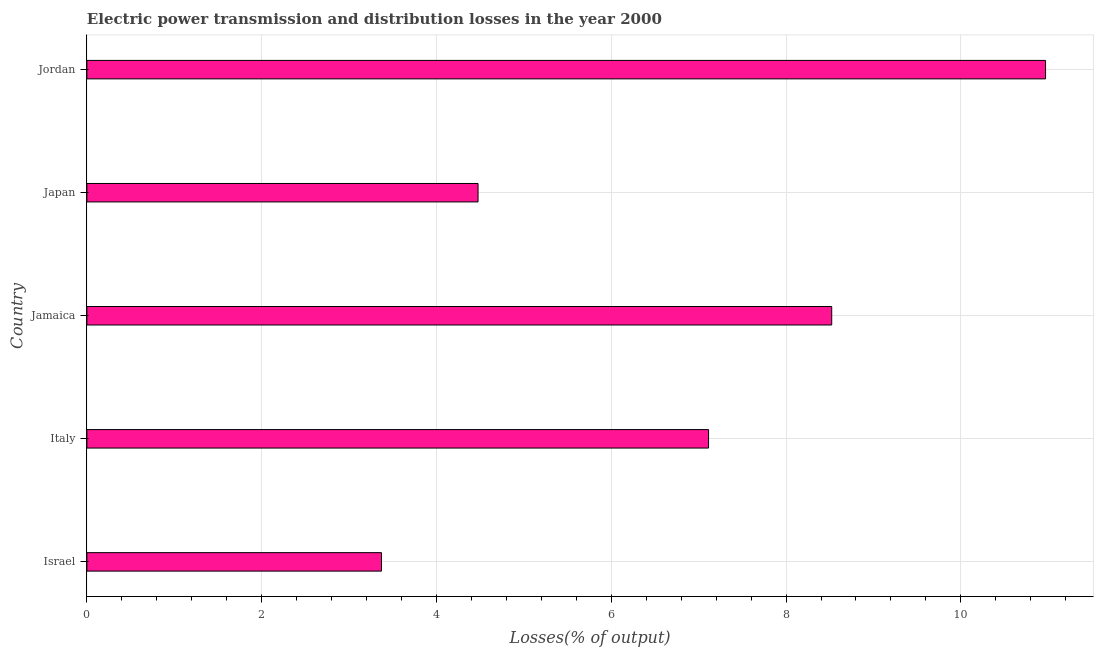Does the graph contain grids?
Your response must be concise. Yes. What is the title of the graph?
Offer a terse response. Electric power transmission and distribution losses in the year 2000. What is the label or title of the X-axis?
Your answer should be very brief. Losses(% of output). What is the electric power transmission and distribution losses in Israel?
Ensure brevity in your answer.  3.37. Across all countries, what is the maximum electric power transmission and distribution losses?
Your answer should be compact. 10.97. Across all countries, what is the minimum electric power transmission and distribution losses?
Provide a short and direct response. 3.37. In which country was the electric power transmission and distribution losses maximum?
Give a very brief answer. Jordan. What is the sum of the electric power transmission and distribution losses?
Your response must be concise. 34.45. What is the difference between the electric power transmission and distribution losses in Japan and Jordan?
Ensure brevity in your answer.  -6.49. What is the average electric power transmission and distribution losses per country?
Offer a very short reply. 6.89. What is the median electric power transmission and distribution losses?
Keep it short and to the point. 7.11. In how many countries, is the electric power transmission and distribution losses greater than 6 %?
Provide a short and direct response. 3. What is the ratio of the electric power transmission and distribution losses in Israel to that in Italy?
Ensure brevity in your answer.  0.47. What is the difference between the highest and the second highest electric power transmission and distribution losses?
Offer a very short reply. 2.45. What is the difference between the highest and the lowest electric power transmission and distribution losses?
Give a very brief answer. 7.6. Are the values on the major ticks of X-axis written in scientific E-notation?
Your answer should be compact. No. What is the Losses(% of output) of Israel?
Ensure brevity in your answer.  3.37. What is the Losses(% of output) of Italy?
Your response must be concise. 7.11. What is the Losses(% of output) in Jamaica?
Give a very brief answer. 8.52. What is the Losses(% of output) of Japan?
Ensure brevity in your answer.  4.48. What is the Losses(% of output) of Jordan?
Give a very brief answer. 10.97. What is the difference between the Losses(% of output) in Israel and Italy?
Ensure brevity in your answer.  -3.74. What is the difference between the Losses(% of output) in Israel and Jamaica?
Your answer should be compact. -5.15. What is the difference between the Losses(% of output) in Israel and Japan?
Your answer should be compact. -1.1. What is the difference between the Losses(% of output) in Israel and Jordan?
Your response must be concise. -7.6. What is the difference between the Losses(% of output) in Italy and Jamaica?
Your answer should be compact. -1.41. What is the difference between the Losses(% of output) in Italy and Japan?
Ensure brevity in your answer.  2.64. What is the difference between the Losses(% of output) in Italy and Jordan?
Your answer should be compact. -3.86. What is the difference between the Losses(% of output) in Jamaica and Japan?
Offer a terse response. 4.05. What is the difference between the Losses(% of output) in Jamaica and Jordan?
Provide a short and direct response. -2.45. What is the difference between the Losses(% of output) in Japan and Jordan?
Offer a very short reply. -6.49. What is the ratio of the Losses(% of output) in Israel to that in Italy?
Offer a terse response. 0.47. What is the ratio of the Losses(% of output) in Israel to that in Jamaica?
Your answer should be compact. 0.4. What is the ratio of the Losses(% of output) in Israel to that in Japan?
Offer a terse response. 0.75. What is the ratio of the Losses(% of output) in Israel to that in Jordan?
Offer a very short reply. 0.31. What is the ratio of the Losses(% of output) in Italy to that in Jamaica?
Give a very brief answer. 0.83. What is the ratio of the Losses(% of output) in Italy to that in Japan?
Your answer should be compact. 1.59. What is the ratio of the Losses(% of output) in Italy to that in Jordan?
Ensure brevity in your answer.  0.65. What is the ratio of the Losses(% of output) in Jamaica to that in Japan?
Keep it short and to the point. 1.9. What is the ratio of the Losses(% of output) in Jamaica to that in Jordan?
Your answer should be very brief. 0.78. What is the ratio of the Losses(% of output) in Japan to that in Jordan?
Provide a succinct answer. 0.41. 